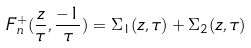Convert formula to latex. <formula><loc_0><loc_0><loc_500><loc_500>F _ { n } ^ { + } ( \frac { z } { \tau } , \frac { - 1 } { \tau } ) = \Sigma _ { 1 } ( z , \tau ) + \Sigma _ { 2 } ( z , \tau )</formula> 